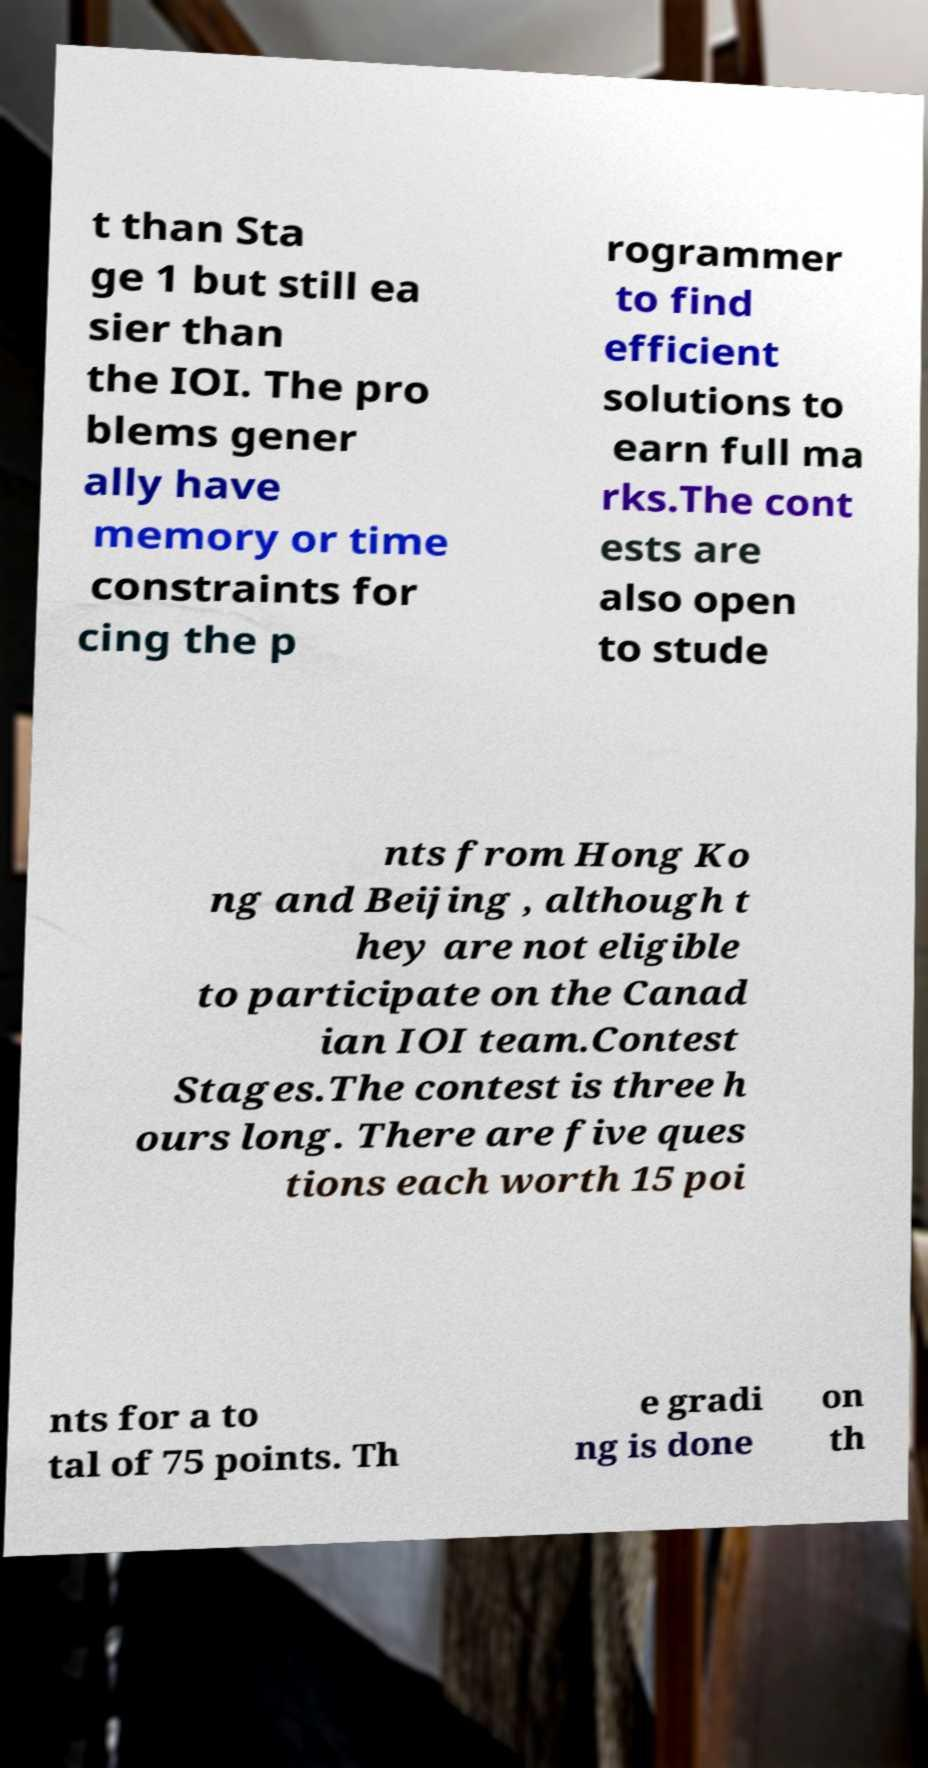I need the written content from this picture converted into text. Can you do that? t than Sta ge 1 but still ea sier than the IOI. The pro blems gener ally have memory or time constraints for cing the p rogrammer to find efficient solutions to earn full ma rks.The cont ests are also open to stude nts from Hong Ko ng and Beijing , although t hey are not eligible to participate on the Canad ian IOI team.Contest Stages.The contest is three h ours long. There are five ques tions each worth 15 poi nts for a to tal of 75 points. Th e gradi ng is done on th 